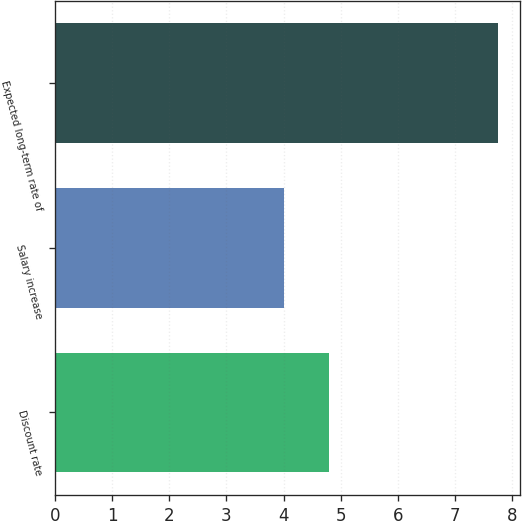Convert chart to OTSL. <chart><loc_0><loc_0><loc_500><loc_500><bar_chart><fcel>Discount rate<fcel>Salary increase<fcel>Expected long-term rate of<nl><fcel>4.8<fcel>4<fcel>7.75<nl></chart> 